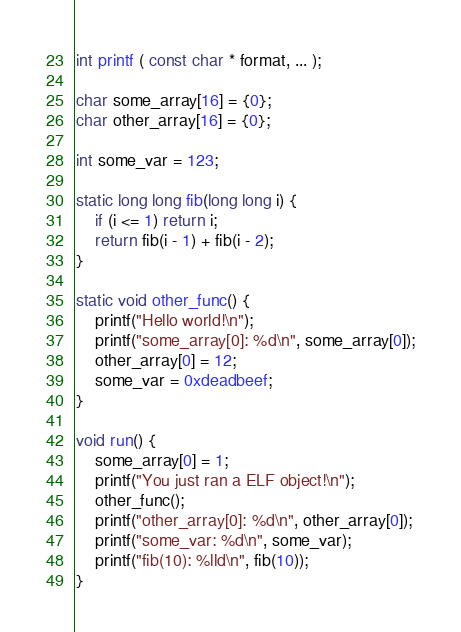Convert code to text. <code><loc_0><loc_0><loc_500><loc_500><_C_>int printf ( const char * format, ... );

char some_array[16] = {0};
char other_array[16] = {0};

int some_var = 123;

static long long fib(long long i) {
    if (i <= 1) return i;
    return fib(i - 1) + fib(i - 2);
}

static void other_func() {
    printf("Hello world!\n");
    printf("some_array[0]: %d\n", some_array[0]);
    other_array[0] = 12;
    some_var = 0xdeadbeef;
}

void run() {
    some_array[0] = 1;
    printf("You just ran a ELF object!\n");
    other_func();
    printf("other_array[0]: %d\n", other_array[0]);
    printf("some_var: %d\n", some_var);
    printf("fib(10): %lld\n", fib(10));
}
</code> 